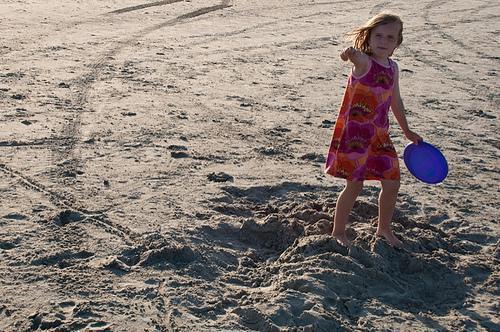How many birds are in the photo?
Give a very brief answer. 0. 